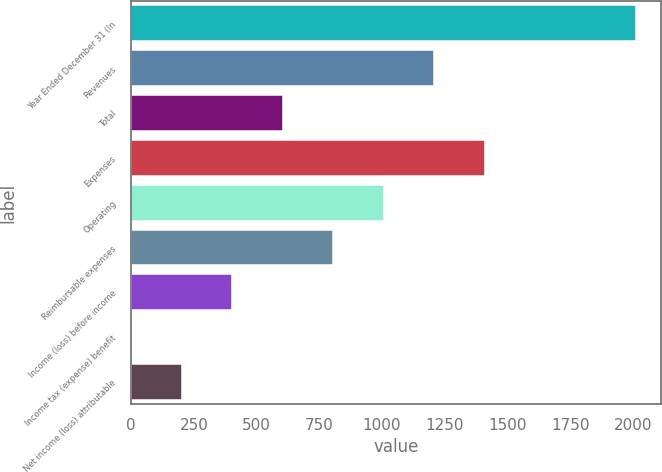Convert chart to OTSL. <chart><loc_0><loc_0><loc_500><loc_500><bar_chart><fcel>Year Ended December 31 (In<fcel>Revenues<fcel>Total<fcel>Expenses<fcel>Operating<fcel>Reimbursable expenses<fcel>Income (loss) before income<fcel>Income tax (expense) benefit<fcel>Net income (loss) attributable<nl><fcel>2013<fcel>1208.2<fcel>604.6<fcel>1409.4<fcel>1007<fcel>805.8<fcel>403.4<fcel>1<fcel>202.2<nl></chart> 